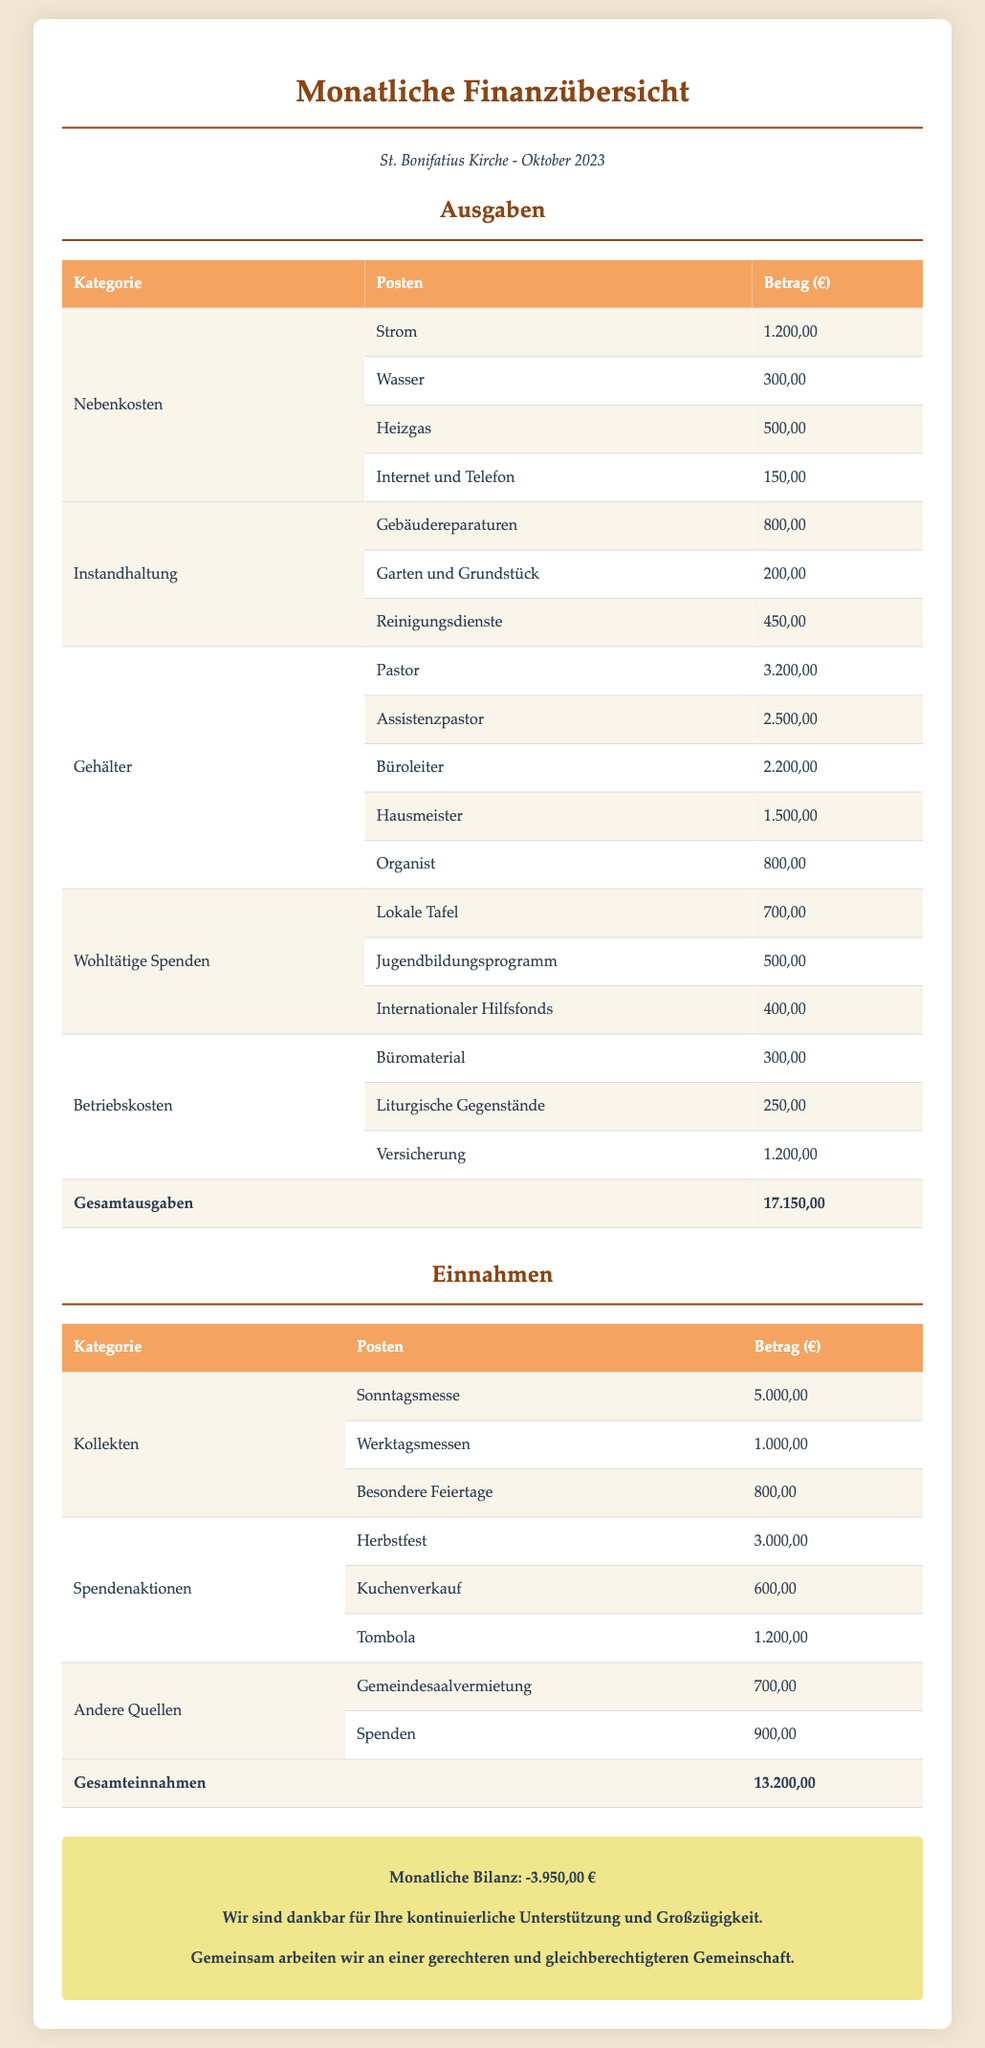Wie hoch sind die Gesamtausgaben? Die Gesamtausgaben sind die Summe aller Ausgaben in der Tabelle unter "Ausgaben", die hier 17.150,00 € beträgt.
Answer: 17.150,00 € Wie viel wurde für den Pastor ausgegeben? Der Betrag für den Pastor ist in der Tabellenzeile unter Gehälter aufgeführt.
Answer: 3.200,00 € Welche Spende wurde an den Internationalen Hilfsfonds geleistet? Die Spende an den Internationalen Hilfsfonds ist in der Zeile unter Wohltätige Spenden zu finden.
Answer: 400,00 € Was betrugen die Einnahmen aus der Sonntagsmesse? Die Einnahmen aus der Sonntagsmesse sind in der Tabelle unter "Kollekten" aufgeführt.
Answer: 5.000,00 € Wie hoch ist die monatliche Bilanz? Die monatliche Bilanz ist die Differenz zwischen Gesamteinnahmen und Gesamtausgaben, hier -3.950,00 €.
Answer: -3.950,00 € Welche Kategorie hat die höchsten Ausgaben? Um die höchsten Ausgaben herauszufinden, muss man die einzelnen Ausgaben in jeder Kategorie betrachten. Hier ist es Gehälter.
Answer: Gehälter Wie viel wurde insgesamt für Nebenkosten ausgegeben? Der Gesamtbetrag für Nebenkosten ist die Summe der Posten unter "Nebenkosten".
Answer: 2.150,00 € Wie viele Einnahmen wurden durch die Tombola generiert? Die Einnahmen der Tombola sind in der entsprechenden Zeile innerhalb der Spendenaktionen-Tabelle aufgeführt.
Answer: 1.200,00 € Wie viel Geld wurde durch den Kuchenverkauf eingeholt? Der Betrag aus dem Kuchenverkauf ist in der Tabelle unter "Spendenaktionen" zu finden.
Answer: 600,00 € Wo wurde die Gesamtausgaben aufgeführt? Die Gesamtausgaben sind in der letzten Zeile der Tabelle unter "Ausgaben" angegeben.
Answer: Gesamtausgaben 